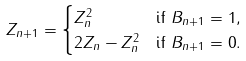Convert formula to latex. <formula><loc_0><loc_0><loc_500><loc_500>Z _ { n + 1 } & = \begin{cases} Z _ { n } ^ { 2 } & \text {if $B_{n+1} = 1$} , \\ 2 Z _ { n } - Z _ { n } ^ { 2 } & \text {if $B_{n+1} = 0$} . \end{cases}</formula> 